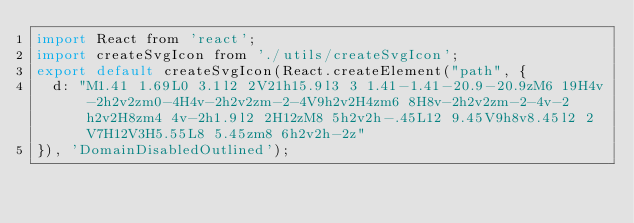Convert code to text. <code><loc_0><loc_0><loc_500><loc_500><_JavaScript_>import React from 'react';
import createSvgIcon from './utils/createSvgIcon';
export default createSvgIcon(React.createElement("path", {
  d: "M1.41 1.69L0 3.1l2 2V21h15.9l3 3 1.41-1.41-20.9-20.9zM6 19H4v-2h2v2zm0-4H4v-2h2v2zm-2-4V9h2v2H4zm6 8H8v-2h2v2zm-2-4v-2h2v2H8zm4 4v-2h1.9l2 2H12zM8 5h2v2h-.45L12 9.45V9h8v8.45l2 2V7H12V3H5.55L8 5.45zm8 6h2v2h-2z"
}), 'DomainDisabledOutlined');</code> 